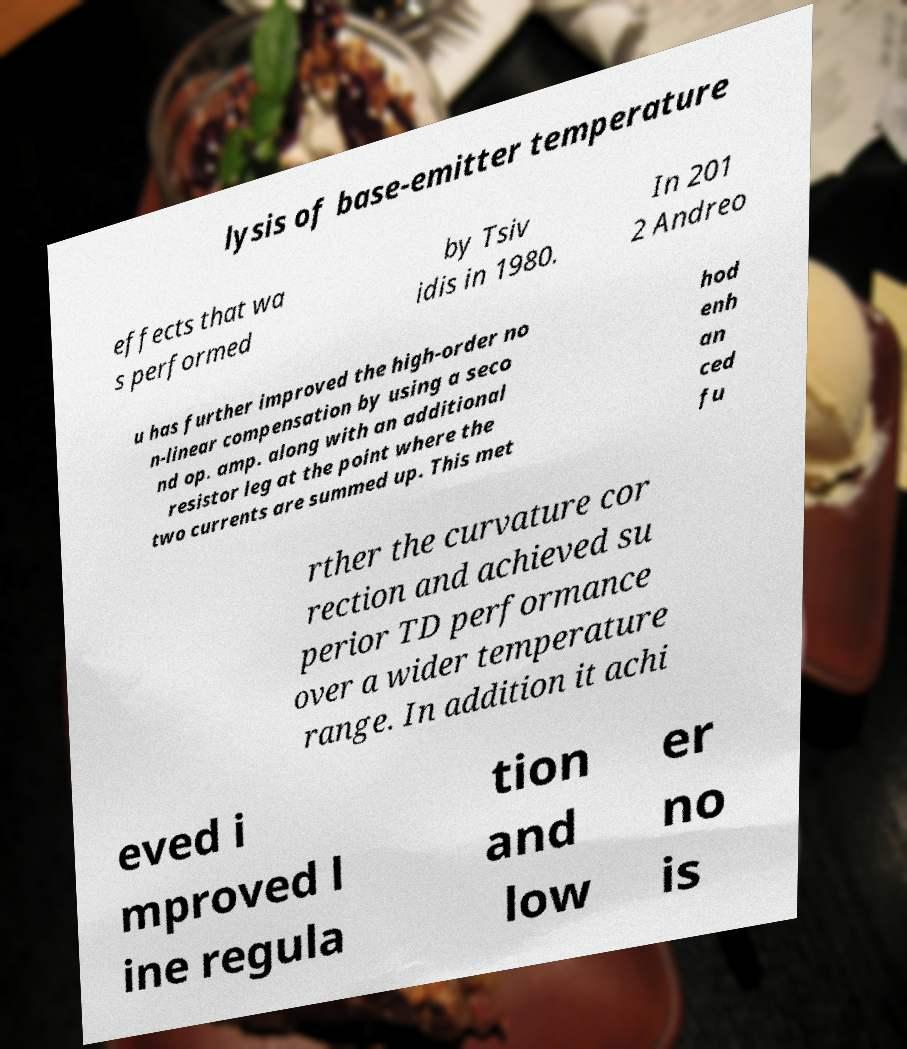Please read and relay the text visible in this image. What does it say? lysis of base-emitter temperature effects that wa s performed by Tsiv idis in 1980. In 201 2 Andreo u has further improved the high-order no n-linear compensation by using a seco nd op. amp. along with an additional resistor leg at the point where the two currents are summed up. This met hod enh an ced fu rther the curvature cor rection and achieved su perior TD performance over a wider temperature range. In addition it achi eved i mproved l ine regula tion and low er no is 